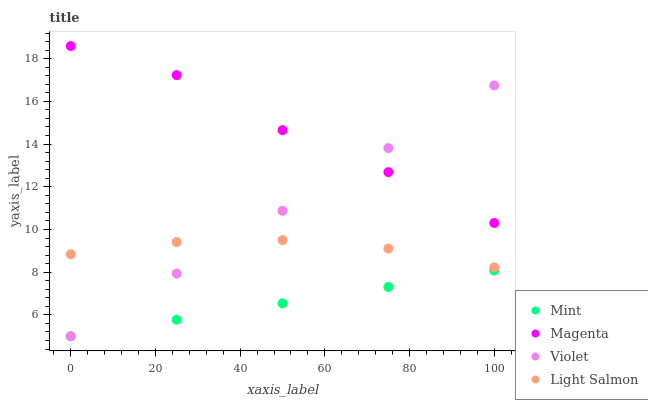Does Mint have the minimum area under the curve?
Answer yes or no. Yes. Does Magenta have the maximum area under the curve?
Answer yes or no. Yes. Does Light Salmon have the minimum area under the curve?
Answer yes or no. No. Does Light Salmon have the maximum area under the curve?
Answer yes or no. No. Is Mint the smoothest?
Answer yes or no. Yes. Is Magenta the roughest?
Answer yes or no. Yes. Is Light Salmon the smoothest?
Answer yes or no. No. Is Light Salmon the roughest?
Answer yes or no. No. Does Mint have the lowest value?
Answer yes or no. Yes. Does Light Salmon have the lowest value?
Answer yes or no. No. Does Magenta have the highest value?
Answer yes or no. Yes. Does Light Salmon have the highest value?
Answer yes or no. No. Is Mint less than Magenta?
Answer yes or no. Yes. Is Magenta greater than Light Salmon?
Answer yes or no. Yes. Does Mint intersect Violet?
Answer yes or no. Yes. Is Mint less than Violet?
Answer yes or no. No. Is Mint greater than Violet?
Answer yes or no. No. Does Mint intersect Magenta?
Answer yes or no. No. 